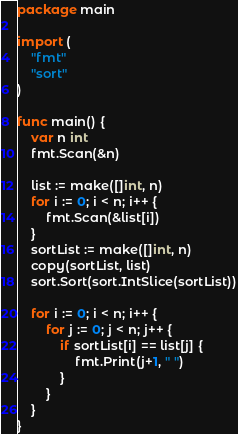<code> <loc_0><loc_0><loc_500><loc_500><_Go_>package main

import (
	"fmt"
	"sort"
)

func main() {
	var n int
	fmt.Scan(&n)

	list := make([]int, n)
	for i := 0; i < n; i++ {
		fmt.Scan(&list[i])
	}
	sortList := make([]int, n)
	copy(sortList, list)
	sort.Sort(sort.IntSlice(sortList))

	for i := 0; i < n; i++ {
		for j := 0; j < n; j++ {
			if sortList[i] == list[j] {
				fmt.Print(j+1, " ")
			}
		}
	}
}
</code> 